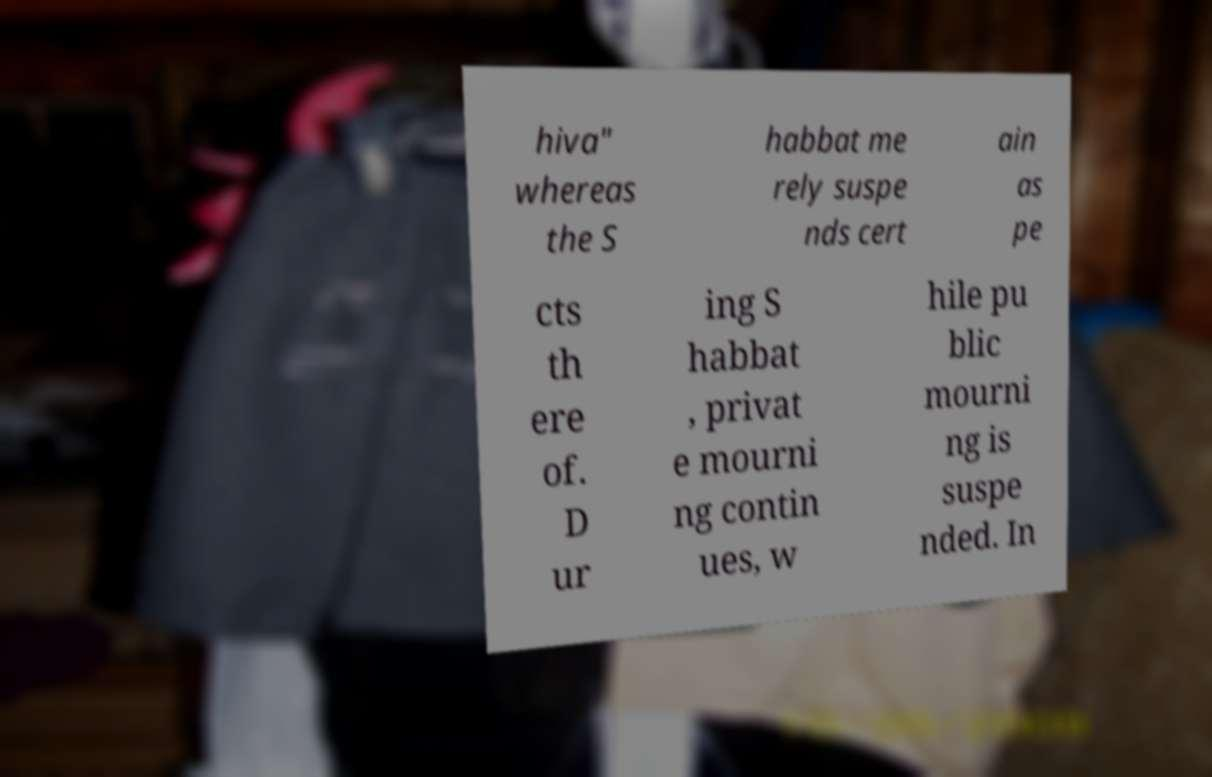I need the written content from this picture converted into text. Can you do that? hiva" whereas the S habbat me rely suspe nds cert ain as pe cts th ere of. D ur ing S habbat , privat e mourni ng contin ues, w hile pu blic mourni ng is suspe nded. In 